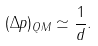Convert formula to latex. <formula><loc_0><loc_0><loc_500><loc_500>( \Delta p ) _ { Q M } \simeq \frac { 1 } { d } .</formula> 